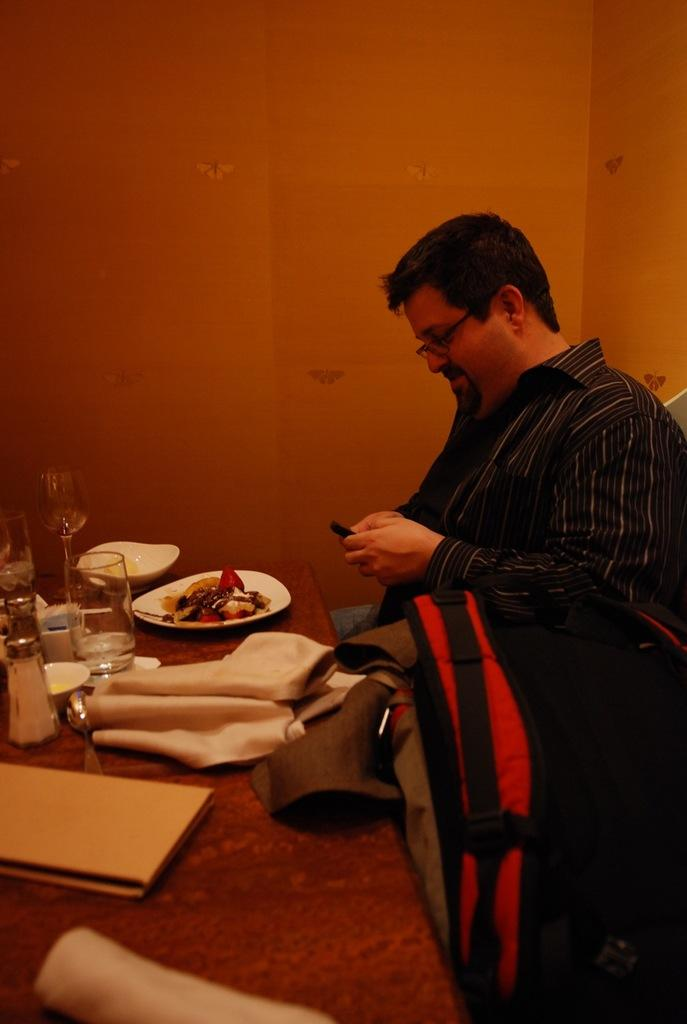What is the man in the image doing? The man is standing in the image, holding a bag. Where is the man standing in relation to other objects in the image? The man is standing near a table. What items can be seen on the table in the image? There are files, napkins, food, plates, glasses, salt and pepper, and a bowl on the table. What is the background of the image? There is a wall in the background of the image. How many women are present in the image, and what are they wearing? There are no women present in the image. What angle is the ornament hanging from the ceiling in the image? There is no ornament present in the image. 